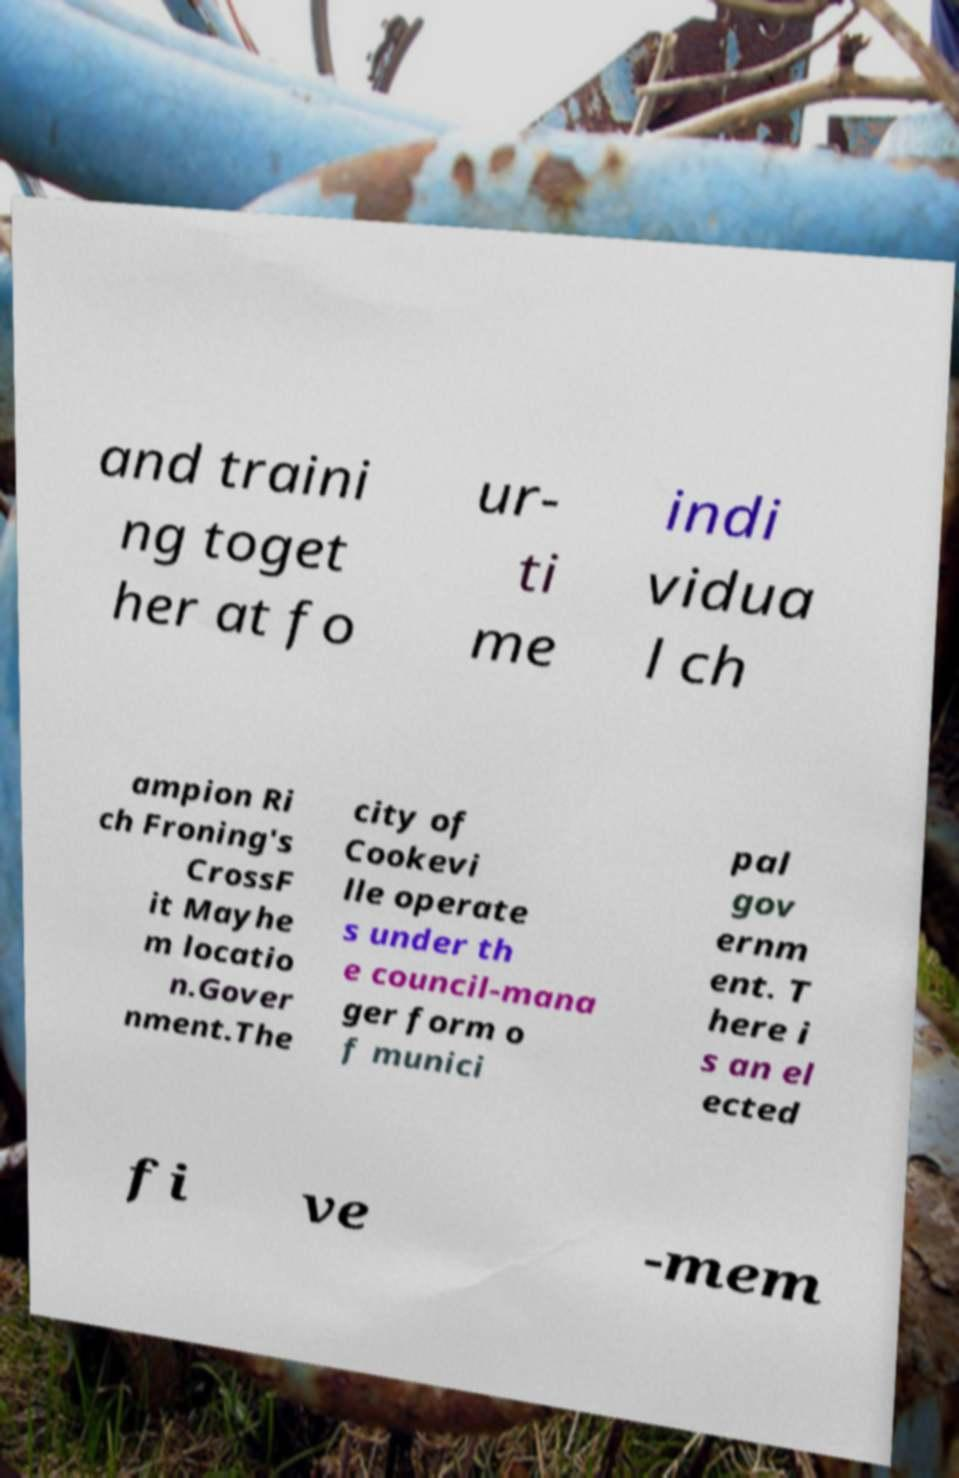Could you extract and type out the text from this image? and traini ng toget her at fo ur- ti me indi vidua l ch ampion Ri ch Froning's CrossF it Mayhe m locatio n.Gover nment.The city of Cookevi lle operate s under th e council-mana ger form o f munici pal gov ernm ent. T here i s an el ected fi ve -mem 